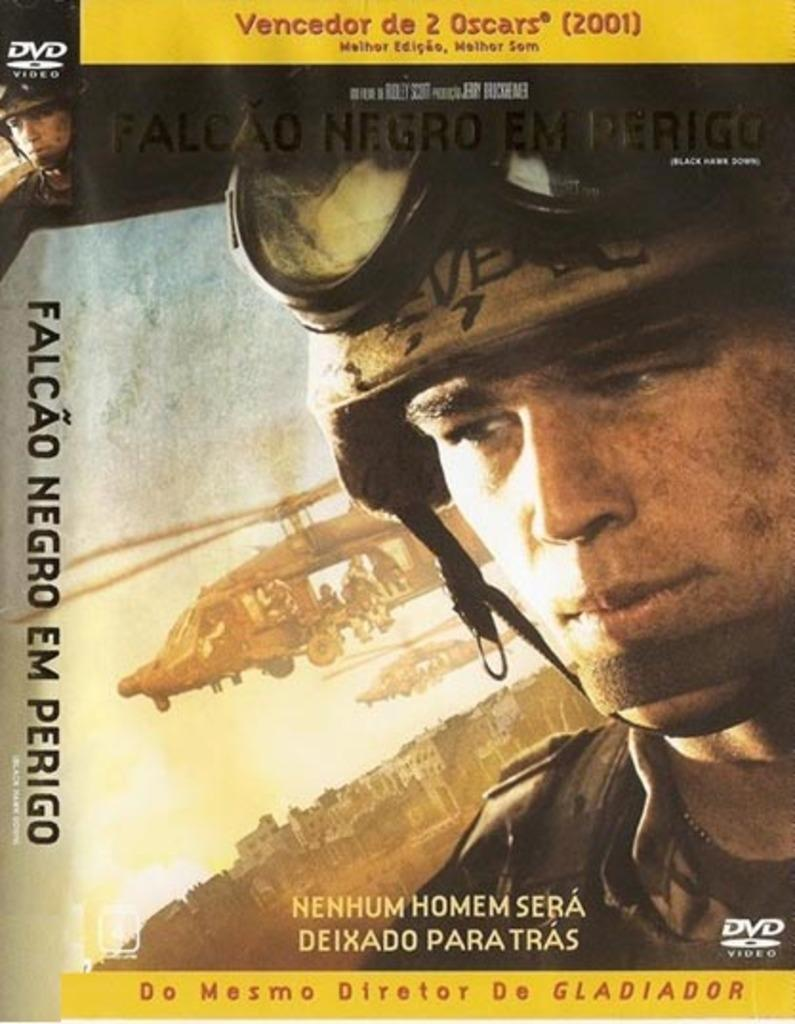Provide a one-sentence caption for the provided image. a dvd that has been nomincated for 2 oscars. 